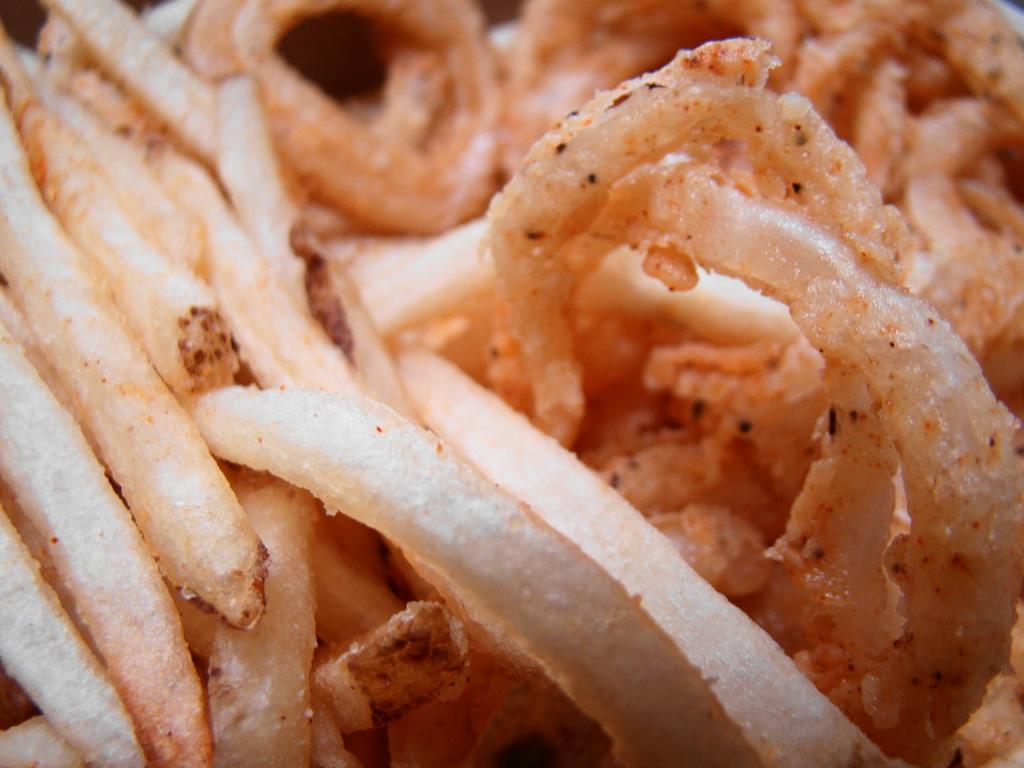What is the main subject of the image? There is a food item in the image. What time of day is the father enjoying the food item in the image? There is no father or indication of time of day present in the image; it only features a food item. 